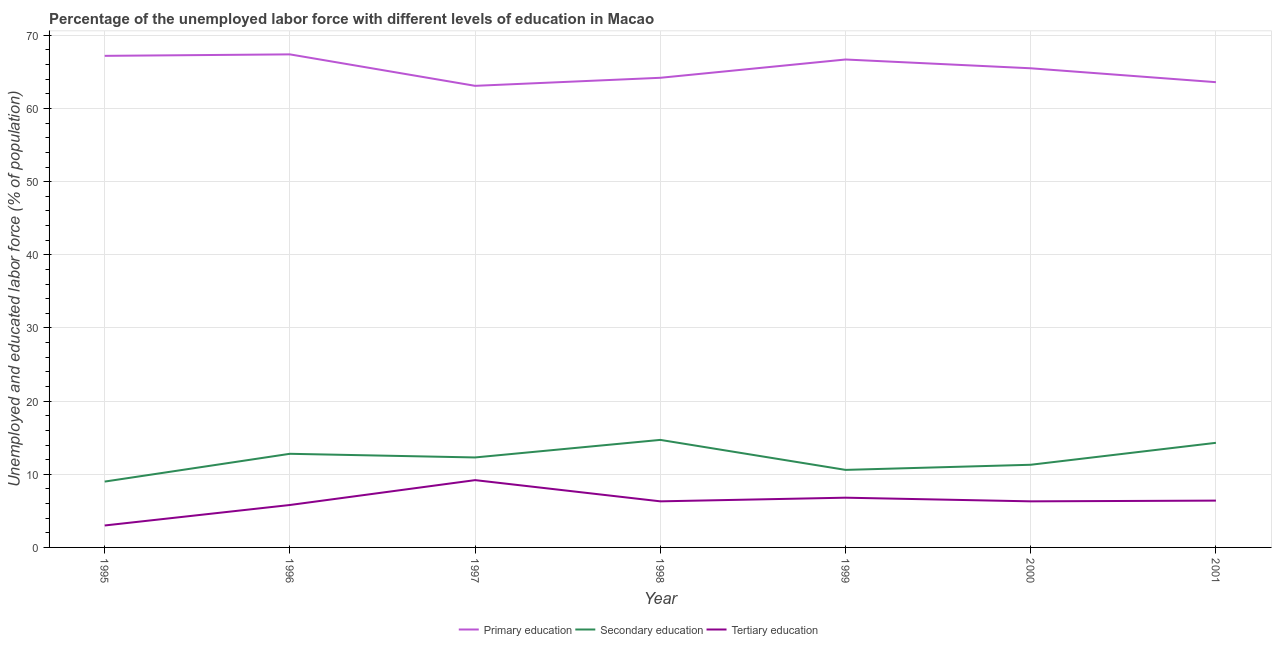Does the line corresponding to percentage of labor force who received secondary education intersect with the line corresponding to percentage of labor force who received tertiary education?
Keep it short and to the point. No. What is the percentage of labor force who received tertiary education in 2000?
Offer a very short reply. 6.3. Across all years, what is the maximum percentage of labor force who received primary education?
Provide a short and direct response. 67.4. Across all years, what is the minimum percentage of labor force who received tertiary education?
Keep it short and to the point. 3. In which year was the percentage of labor force who received secondary education maximum?
Give a very brief answer. 1998. In which year was the percentage of labor force who received primary education minimum?
Offer a terse response. 1997. What is the total percentage of labor force who received secondary education in the graph?
Your answer should be compact. 85. What is the difference between the percentage of labor force who received primary education in 1997 and that in 1998?
Offer a very short reply. -1.1. What is the difference between the percentage of labor force who received primary education in 1997 and the percentage of labor force who received secondary education in 1995?
Ensure brevity in your answer.  54.1. What is the average percentage of labor force who received secondary education per year?
Offer a very short reply. 12.14. In the year 2000, what is the difference between the percentage of labor force who received secondary education and percentage of labor force who received primary education?
Provide a succinct answer. -54.2. What is the ratio of the percentage of labor force who received secondary education in 1995 to that in 1997?
Provide a succinct answer. 0.73. Is the difference between the percentage of labor force who received primary education in 1996 and 2001 greater than the difference between the percentage of labor force who received secondary education in 1996 and 2001?
Make the answer very short. Yes. What is the difference between the highest and the second highest percentage of labor force who received primary education?
Your answer should be compact. 0.2. What is the difference between the highest and the lowest percentage of labor force who received tertiary education?
Keep it short and to the point. 6.2. In how many years, is the percentage of labor force who received secondary education greater than the average percentage of labor force who received secondary education taken over all years?
Keep it short and to the point. 4. Is the sum of the percentage of labor force who received tertiary education in 1997 and 2001 greater than the maximum percentage of labor force who received primary education across all years?
Provide a succinct answer. No. Is it the case that in every year, the sum of the percentage of labor force who received primary education and percentage of labor force who received secondary education is greater than the percentage of labor force who received tertiary education?
Ensure brevity in your answer.  Yes. What is the difference between two consecutive major ticks on the Y-axis?
Your answer should be very brief. 10. Does the graph contain any zero values?
Offer a terse response. No. Where does the legend appear in the graph?
Offer a terse response. Bottom center. How many legend labels are there?
Your response must be concise. 3. How are the legend labels stacked?
Offer a very short reply. Horizontal. What is the title of the graph?
Provide a succinct answer. Percentage of the unemployed labor force with different levels of education in Macao. What is the label or title of the X-axis?
Make the answer very short. Year. What is the label or title of the Y-axis?
Offer a terse response. Unemployed and educated labor force (% of population). What is the Unemployed and educated labor force (% of population) in Primary education in 1995?
Ensure brevity in your answer.  67.2. What is the Unemployed and educated labor force (% of population) in Secondary education in 1995?
Your answer should be very brief. 9. What is the Unemployed and educated labor force (% of population) of Tertiary education in 1995?
Offer a terse response. 3. What is the Unemployed and educated labor force (% of population) in Primary education in 1996?
Your answer should be very brief. 67.4. What is the Unemployed and educated labor force (% of population) of Secondary education in 1996?
Ensure brevity in your answer.  12.8. What is the Unemployed and educated labor force (% of population) in Tertiary education in 1996?
Provide a succinct answer. 5.8. What is the Unemployed and educated labor force (% of population) of Primary education in 1997?
Give a very brief answer. 63.1. What is the Unemployed and educated labor force (% of population) of Secondary education in 1997?
Keep it short and to the point. 12.3. What is the Unemployed and educated labor force (% of population) in Tertiary education in 1997?
Offer a terse response. 9.2. What is the Unemployed and educated labor force (% of population) of Primary education in 1998?
Offer a terse response. 64.2. What is the Unemployed and educated labor force (% of population) in Secondary education in 1998?
Ensure brevity in your answer.  14.7. What is the Unemployed and educated labor force (% of population) of Tertiary education in 1998?
Offer a terse response. 6.3. What is the Unemployed and educated labor force (% of population) in Primary education in 1999?
Provide a short and direct response. 66.7. What is the Unemployed and educated labor force (% of population) of Secondary education in 1999?
Keep it short and to the point. 10.6. What is the Unemployed and educated labor force (% of population) of Tertiary education in 1999?
Your answer should be compact. 6.8. What is the Unemployed and educated labor force (% of population) in Primary education in 2000?
Offer a terse response. 65.5. What is the Unemployed and educated labor force (% of population) in Secondary education in 2000?
Your answer should be very brief. 11.3. What is the Unemployed and educated labor force (% of population) in Tertiary education in 2000?
Offer a very short reply. 6.3. What is the Unemployed and educated labor force (% of population) of Primary education in 2001?
Your answer should be very brief. 63.6. What is the Unemployed and educated labor force (% of population) of Secondary education in 2001?
Make the answer very short. 14.3. What is the Unemployed and educated labor force (% of population) in Tertiary education in 2001?
Offer a terse response. 6.4. Across all years, what is the maximum Unemployed and educated labor force (% of population) in Primary education?
Ensure brevity in your answer.  67.4. Across all years, what is the maximum Unemployed and educated labor force (% of population) in Secondary education?
Provide a short and direct response. 14.7. Across all years, what is the maximum Unemployed and educated labor force (% of population) in Tertiary education?
Ensure brevity in your answer.  9.2. Across all years, what is the minimum Unemployed and educated labor force (% of population) of Primary education?
Your answer should be very brief. 63.1. Across all years, what is the minimum Unemployed and educated labor force (% of population) in Tertiary education?
Keep it short and to the point. 3. What is the total Unemployed and educated labor force (% of population) in Primary education in the graph?
Provide a succinct answer. 457.7. What is the total Unemployed and educated labor force (% of population) of Secondary education in the graph?
Give a very brief answer. 85. What is the total Unemployed and educated labor force (% of population) in Tertiary education in the graph?
Make the answer very short. 43.8. What is the difference between the Unemployed and educated labor force (% of population) in Secondary education in 1995 and that in 1997?
Make the answer very short. -3.3. What is the difference between the Unemployed and educated labor force (% of population) of Tertiary education in 1995 and that in 1997?
Keep it short and to the point. -6.2. What is the difference between the Unemployed and educated labor force (% of population) of Tertiary education in 1995 and that in 1998?
Your response must be concise. -3.3. What is the difference between the Unemployed and educated labor force (% of population) in Secondary education in 1995 and that in 1999?
Provide a succinct answer. -1.6. What is the difference between the Unemployed and educated labor force (% of population) of Tertiary education in 1995 and that in 1999?
Your response must be concise. -3.8. What is the difference between the Unemployed and educated labor force (% of population) of Primary education in 1995 and that in 2000?
Make the answer very short. 1.7. What is the difference between the Unemployed and educated labor force (% of population) in Secondary education in 1995 and that in 2000?
Offer a very short reply. -2.3. What is the difference between the Unemployed and educated labor force (% of population) of Primary education in 1995 and that in 2001?
Provide a short and direct response. 3.6. What is the difference between the Unemployed and educated labor force (% of population) of Secondary education in 1996 and that in 1997?
Offer a very short reply. 0.5. What is the difference between the Unemployed and educated labor force (% of population) of Primary education in 1996 and that in 1998?
Provide a short and direct response. 3.2. What is the difference between the Unemployed and educated labor force (% of population) of Secondary education in 1996 and that in 1999?
Your response must be concise. 2.2. What is the difference between the Unemployed and educated labor force (% of population) in Tertiary education in 1996 and that in 2000?
Give a very brief answer. -0.5. What is the difference between the Unemployed and educated labor force (% of population) in Tertiary education in 1996 and that in 2001?
Your answer should be very brief. -0.6. What is the difference between the Unemployed and educated labor force (% of population) in Primary education in 1997 and that in 1998?
Keep it short and to the point. -1.1. What is the difference between the Unemployed and educated labor force (% of population) of Secondary education in 1997 and that in 1998?
Give a very brief answer. -2.4. What is the difference between the Unemployed and educated labor force (% of population) of Tertiary education in 1997 and that in 1998?
Ensure brevity in your answer.  2.9. What is the difference between the Unemployed and educated labor force (% of population) in Primary education in 1997 and that in 1999?
Offer a very short reply. -3.6. What is the difference between the Unemployed and educated labor force (% of population) of Tertiary education in 1997 and that in 1999?
Keep it short and to the point. 2.4. What is the difference between the Unemployed and educated labor force (% of population) of Primary education in 1997 and that in 2000?
Give a very brief answer. -2.4. What is the difference between the Unemployed and educated labor force (% of population) of Tertiary education in 1997 and that in 2000?
Keep it short and to the point. 2.9. What is the difference between the Unemployed and educated labor force (% of population) of Tertiary education in 1997 and that in 2001?
Offer a very short reply. 2.8. What is the difference between the Unemployed and educated labor force (% of population) of Secondary education in 1998 and that in 1999?
Ensure brevity in your answer.  4.1. What is the difference between the Unemployed and educated labor force (% of population) of Primary education in 1998 and that in 2000?
Provide a succinct answer. -1.3. What is the difference between the Unemployed and educated labor force (% of population) of Primary education in 1998 and that in 2001?
Ensure brevity in your answer.  0.6. What is the difference between the Unemployed and educated labor force (% of population) of Secondary education in 1998 and that in 2001?
Your answer should be very brief. 0.4. What is the difference between the Unemployed and educated labor force (% of population) in Primary education in 1999 and that in 2000?
Your answer should be compact. 1.2. What is the difference between the Unemployed and educated labor force (% of population) of Secondary education in 1999 and that in 2001?
Your answer should be compact. -3.7. What is the difference between the Unemployed and educated labor force (% of population) in Tertiary education in 1999 and that in 2001?
Provide a succinct answer. 0.4. What is the difference between the Unemployed and educated labor force (% of population) in Secondary education in 2000 and that in 2001?
Provide a succinct answer. -3. What is the difference between the Unemployed and educated labor force (% of population) of Tertiary education in 2000 and that in 2001?
Make the answer very short. -0.1. What is the difference between the Unemployed and educated labor force (% of population) in Primary education in 1995 and the Unemployed and educated labor force (% of population) in Secondary education in 1996?
Keep it short and to the point. 54.4. What is the difference between the Unemployed and educated labor force (% of population) in Primary education in 1995 and the Unemployed and educated labor force (% of population) in Tertiary education in 1996?
Your answer should be compact. 61.4. What is the difference between the Unemployed and educated labor force (% of population) in Primary education in 1995 and the Unemployed and educated labor force (% of population) in Secondary education in 1997?
Provide a succinct answer. 54.9. What is the difference between the Unemployed and educated labor force (% of population) of Secondary education in 1995 and the Unemployed and educated labor force (% of population) of Tertiary education in 1997?
Provide a succinct answer. -0.2. What is the difference between the Unemployed and educated labor force (% of population) in Primary education in 1995 and the Unemployed and educated labor force (% of population) in Secondary education in 1998?
Provide a succinct answer. 52.5. What is the difference between the Unemployed and educated labor force (% of population) of Primary education in 1995 and the Unemployed and educated labor force (% of population) of Tertiary education in 1998?
Make the answer very short. 60.9. What is the difference between the Unemployed and educated labor force (% of population) in Secondary education in 1995 and the Unemployed and educated labor force (% of population) in Tertiary education in 1998?
Offer a very short reply. 2.7. What is the difference between the Unemployed and educated labor force (% of population) of Primary education in 1995 and the Unemployed and educated labor force (% of population) of Secondary education in 1999?
Your response must be concise. 56.6. What is the difference between the Unemployed and educated labor force (% of population) of Primary education in 1995 and the Unemployed and educated labor force (% of population) of Tertiary education in 1999?
Keep it short and to the point. 60.4. What is the difference between the Unemployed and educated labor force (% of population) of Secondary education in 1995 and the Unemployed and educated labor force (% of population) of Tertiary education in 1999?
Your response must be concise. 2.2. What is the difference between the Unemployed and educated labor force (% of population) of Primary education in 1995 and the Unemployed and educated labor force (% of population) of Secondary education in 2000?
Make the answer very short. 55.9. What is the difference between the Unemployed and educated labor force (% of population) in Primary education in 1995 and the Unemployed and educated labor force (% of population) in Tertiary education in 2000?
Your answer should be very brief. 60.9. What is the difference between the Unemployed and educated labor force (% of population) in Primary education in 1995 and the Unemployed and educated labor force (% of population) in Secondary education in 2001?
Your response must be concise. 52.9. What is the difference between the Unemployed and educated labor force (% of population) in Primary education in 1995 and the Unemployed and educated labor force (% of population) in Tertiary education in 2001?
Your response must be concise. 60.8. What is the difference between the Unemployed and educated labor force (% of population) of Primary education in 1996 and the Unemployed and educated labor force (% of population) of Secondary education in 1997?
Make the answer very short. 55.1. What is the difference between the Unemployed and educated labor force (% of population) in Primary education in 1996 and the Unemployed and educated labor force (% of population) in Tertiary education in 1997?
Offer a very short reply. 58.2. What is the difference between the Unemployed and educated labor force (% of population) of Primary education in 1996 and the Unemployed and educated labor force (% of population) of Secondary education in 1998?
Provide a short and direct response. 52.7. What is the difference between the Unemployed and educated labor force (% of population) in Primary education in 1996 and the Unemployed and educated labor force (% of population) in Tertiary education in 1998?
Offer a very short reply. 61.1. What is the difference between the Unemployed and educated labor force (% of population) in Primary education in 1996 and the Unemployed and educated labor force (% of population) in Secondary education in 1999?
Give a very brief answer. 56.8. What is the difference between the Unemployed and educated labor force (% of population) of Primary education in 1996 and the Unemployed and educated labor force (% of population) of Tertiary education in 1999?
Offer a very short reply. 60.6. What is the difference between the Unemployed and educated labor force (% of population) of Primary education in 1996 and the Unemployed and educated labor force (% of population) of Secondary education in 2000?
Keep it short and to the point. 56.1. What is the difference between the Unemployed and educated labor force (% of population) in Primary education in 1996 and the Unemployed and educated labor force (% of population) in Tertiary education in 2000?
Your answer should be compact. 61.1. What is the difference between the Unemployed and educated labor force (% of population) in Secondary education in 1996 and the Unemployed and educated labor force (% of population) in Tertiary education in 2000?
Your answer should be compact. 6.5. What is the difference between the Unemployed and educated labor force (% of population) of Primary education in 1996 and the Unemployed and educated labor force (% of population) of Secondary education in 2001?
Your response must be concise. 53.1. What is the difference between the Unemployed and educated labor force (% of population) in Secondary education in 1996 and the Unemployed and educated labor force (% of population) in Tertiary education in 2001?
Your answer should be very brief. 6.4. What is the difference between the Unemployed and educated labor force (% of population) in Primary education in 1997 and the Unemployed and educated labor force (% of population) in Secondary education in 1998?
Provide a succinct answer. 48.4. What is the difference between the Unemployed and educated labor force (% of population) of Primary education in 1997 and the Unemployed and educated labor force (% of population) of Tertiary education in 1998?
Ensure brevity in your answer.  56.8. What is the difference between the Unemployed and educated labor force (% of population) of Primary education in 1997 and the Unemployed and educated labor force (% of population) of Secondary education in 1999?
Ensure brevity in your answer.  52.5. What is the difference between the Unemployed and educated labor force (% of population) of Primary education in 1997 and the Unemployed and educated labor force (% of population) of Tertiary education in 1999?
Your answer should be compact. 56.3. What is the difference between the Unemployed and educated labor force (% of population) of Secondary education in 1997 and the Unemployed and educated labor force (% of population) of Tertiary education in 1999?
Provide a succinct answer. 5.5. What is the difference between the Unemployed and educated labor force (% of population) of Primary education in 1997 and the Unemployed and educated labor force (% of population) of Secondary education in 2000?
Give a very brief answer. 51.8. What is the difference between the Unemployed and educated labor force (% of population) of Primary education in 1997 and the Unemployed and educated labor force (% of population) of Tertiary education in 2000?
Give a very brief answer. 56.8. What is the difference between the Unemployed and educated labor force (% of population) in Primary education in 1997 and the Unemployed and educated labor force (% of population) in Secondary education in 2001?
Offer a terse response. 48.8. What is the difference between the Unemployed and educated labor force (% of population) of Primary education in 1997 and the Unemployed and educated labor force (% of population) of Tertiary education in 2001?
Offer a very short reply. 56.7. What is the difference between the Unemployed and educated labor force (% of population) in Primary education in 1998 and the Unemployed and educated labor force (% of population) in Secondary education in 1999?
Give a very brief answer. 53.6. What is the difference between the Unemployed and educated labor force (% of population) in Primary education in 1998 and the Unemployed and educated labor force (% of population) in Tertiary education in 1999?
Make the answer very short. 57.4. What is the difference between the Unemployed and educated labor force (% of population) in Secondary education in 1998 and the Unemployed and educated labor force (% of population) in Tertiary education in 1999?
Provide a short and direct response. 7.9. What is the difference between the Unemployed and educated labor force (% of population) of Primary education in 1998 and the Unemployed and educated labor force (% of population) of Secondary education in 2000?
Make the answer very short. 52.9. What is the difference between the Unemployed and educated labor force (% of population) in Primary education in 1998 and the Unemployed and educated labor force (% of population) in Tertiary education in 2000?
Your answer should be very brief. 57.9. What is the difference between the Unemployed and educated labor force (% of population) in Primary education in 1998 and the Unemployed and educated labor force (% of population) in Secondary education in 2001?
Provide a short and direct response. 49.9. What is the difference between the Unemployed and educated labor force (% of population) in Primary education in 1998 and the Unemployed and educated labor force (% of population) in Tertiary education in 2001?
Provide a succinct answer. 57.8. What is the difference between the Unemployed and educated labor force (% of population) of Secondary education in 1998 and the Unemployed and educated labor force (% of population) of Tertiary education in 2001?
Make the answer very short. 8.3. What is the difference between the Unemployed and educated labor force (% of population) in Primary education in 1999 and the Unemployed and educated labor force (% of population) in Secondary education in 2000?
Provide a short and direct response. 55.4. What is the difference between the Unemployed and educated labor force (% of population) of Primary education in 1999 and the Unemployed and educated labor force (% of population) of Tertiary education in 2000?
Offer a terse response. 60.4. What is the difference between the Unemployed and educated labor force (% of population) in Primary education in 1999 and the Unemployed and educated labor force (% of population) in Secondary education in 2001?
Make the answer very short. 52.4. What is the difference between the Unemployed and educated labor force (% of population) of Primary education in 1999 and the Unemployed and educated labor force (% of population) of Tertiary education in 2001?
Provide a succinct answer. 60.3. What is the difference between the Unemployed and educated labor force (% of population) of Secondary education in 1999 and the Unemployed and educated labor force (% of population) of Tertiary education in 2001?
Provide a succinct answer. 4.2. What is the difference between the Unemployed and educated labor force (% of population) of Primary education in 2000 and the Unemployed and educated labor force (% of population) of Secondary education in 2001?
Offer a terse response. 51.2. What is the difference between the Unemployed and educated labor force (% of population) in Primary education in 2000 and the Unemployed and educated labor force (% of population) in Tertiary education in 2001?
Provide a short and direct response. 59.1. What is the average Unemployed and educated labor force (% of population) in Primary education per year?
Ensure brevity in your answer.  65.39. What is the average Unemployed and educated labor force (% of population) of Secondary education per year?
Offer a terse response. 12.14. What is the average Unemployed and educated labor force (% of population) of Tertiary education per year?
Ensure brevity in your answer.  6.26. In the year 1995, what is the difference between the Unemployed and educated labor force (% of population) of Primary education and Unemployed and educated labor force (% of population) of Secondary education?
Give a very brief answer. 58.2. In the year 1995, what is the difference between the Unemployed and educated labor force (% of population) in Primary education and Unemployed and educated labor force (% of population) in Tertiary education?
Provide a succinct answer. 64.2. In the year 1995, what is the difference between the Unemployed and educated labor force (% of population) in Secondary education and Unemployed and educated labor force (% of population) in Tertiary education?
Offer a very short reply. 6. In the year 1996, what is the difference between the Unemployed and educated labor force (% of population) of Primary education and Unemployed and educated labor force (% of population) of Secondary education?
Keep it short and to the point. 54.6. In the year 1996, what is the difference between the Unemployed and educated labor force (% of population) in Primary education and Unemployed and educated labor force (% of population) in Tertiary education?
Provide a succinct answer. 61.6. In the year 1997, what is the difference between the Unemployed and educated labor force (% of population) in Primary education and Unemployed and educated labor force (% of population) in Secondary education?
Make the answer very short. 50.8. In the year 1997, what is the difference between the Unemployed and educated labor force (% of population) of Primary education and Unemployed and educated labor force (% of population) of Tertiary education?
Your response must be concise. 53.9. In the year 1998, what is the difference between the Unemployed and educated labor force (% of population) in Primary education and Unemployed and educated labor force (% of population) in Secondary education?
Make the answer very short. 49.5. In the year 1998, what is the difference between the Unemployed and educated labor force (% of population) of Primary education and Unemployed and educated labor force (% of population) of Tertiary education?
Offer a terse response. 57.9. In the year 1999, what is the difference between the Unemployed and educated labor force (% of population) of Primary education and Unemployed and educated labor force (% of population) of Secondary education?
Your answer should be very brief. 56.1. In the year 1999, what is the difference between the Unemployed and educated labor force (% of population) of Primary education and Unemployed and educated labor force (% of population) of Tertiary education?
Your answer should be very brief. 59.9. In the year 1999, what is the difference between the Unemployed and educated labor force (% of population) of Secondary education and Unemployed and educated labor force (% of population) of Tertiary education?
Provide a succinct answer. 3.8. In the year 2000, what is the difference between the Unemployed and educated labor force (% of population) of Primary education and Unemployed and educated labor force (% of population) of Secondary education?
Provide a short and direct response. 54.2. In the year 2000, what is the difference between the Unemployed and educated labor force (% of population) in Primary education and Unemployed and educated labor force (% of population) in Tertiary education?
Keep it short and to the point. 59.2. In the year 2001, what is the difference between the Unemployed and educated labor force (% of population) of Primary education and Unemployed and educated labor force (% of population) of Secondary education?
Provide a succinct answer. 49.3. In the year 2001, what is the difference between the Unemployed and educated labor force (% of population) in Primary education and Unemployed and educated labor force (% of population) in Tertiary education?
Offer a very short reply. 57.2. What is the ratio of the Unemployed and educated labor force (% of population) of Secondary education in 1995 to that in 1996?
Keep it short and to the point. 0.7. What is the ratio of the Unemployed and educated labor force (% of population) in Tertiary education in 1995 to that in 1996?
Offer a very short reply. 0.52. What is the ratio of the Unemployed and educated labor force (% of population) of Primary education in 1995 to that in 1997?
Your response must be concise. 1.06. What is the ratio of the Unemployed and educated labor force (% of population) of Secondary education in 1995 to that in 1997?
Offer a very short reply. 0.73. What is the ratio of the Unemployed and educated labor force (% of population) of Tertiary education in 1995 to that in 1997?
Your response must be concise. 0.33. What is the ratio of the Unemployed and educated labor force (% of population) of Primary education in 1995 to that in 1998?
Offer a very short reply. 1.05. What is the ratio of the Unemployed and educated labor force (% of population) in Secondary education in 1995 to that in 1998?
Give a very brief answer. 0.61. What is the ratio of the Unemployed and educated labor force (% of population) in Tertiary education in 1995 to that in 1998?
Provide a short and direct response. 0.48. What is the ratio of the Unemployed and educated labor force (% of population) of Primary education in 1995 to that in 1999?
Offer a very short reply. 1.01. What is the ratio of the Unemployed and educated labor force (% of population) of Secondary education in 1995 to that in 1999?
Your answer should be compact. 0.85. What is the ratio of the Unemployed and educated labor force (% of population) of Tertiary education in 1995 to that in 1999?
Provide a succinct answer. 0.44. What is the ratio of the Unemployed and educated labor force (% of population) of Primary education in 1995 to that in 2000?
Ensure brevity in your answer.  1.03. What is the ratio of the Unemployed and educated labor force (% of population) of Secondary education in 1995 to that in 2000?
Offer a terse response. 0.8. What is the ratio of the Unemployed and educated labor force (% of population) in Tertiary education in 1995 to that in 2000?
Your answer should be very brief. 0.48. What is the ratio of the Unemployed and educated labor force (% of population) of Primary education in 1995 to that in 2001?
Offer a terse response. 1.06. What is the ratio of the Unemployed and educated labor force (% of population) in Secondary education in 1995 to that in 2001?
Offer a terse response. 0.63. What is the ratio of the Unemployed and educated labor force (% of population) of Tertiary education in 1995 to that in 2001?
Your answer should be compact. 0.47. What is the ratio of the Unemployed and educated labor force (% of population) in Primary education in 1996 to that in 1997?
Make the answer very short. 1.07. What is the ratio of the Unemployed and educated labor force (% of population) in Secondary education in 1996 to that in 1997?
Your answer should be compact. 1.04. What is the ratio of the Unemployed and educated labor force (% of population) in Tertiary education in 1996 to that in 1997?
Offer a terse response. 0.63. What is the ratio of the Unemployed and educated labor force (% of population) in Primary education in 1996 to that in 1998?
Give a very brief answer. 1.05. What is the ratio of the Unemployed and educated labor force (% of population) of Secondary education in 1996 to that in 1998?
Your answer should be very brief. 0.87. What is the ratio of the Unemployed and educated labor force (% of population) in Tertiary education in 1996 to that in 1998?
Provide a short and direct response. 0.92. What is the ratio of the Unemployed and educated labor force (% of population) in Primary education in 1996 to that in 1999?
Your answer should be compact. 1.01. What is the ratio of the Unemployed and educated labor force (% of population) of Secondary education in 1996 to that in 1999?
Give a very brief answer. 1.21. What is the ratio of the Unemployed and educated labor force (% of population) in Tertiary education in 1996 to that in 1999?
Your answer should be very brief. 0.85. What is the ratio of the Unemployed and educated labor force (% of population) in Secondary education in 1996 to that in 2000?
Ensure brevity in your answer.  1.13. What is the ratio of the Unemployed and educated labor force (% of population) in Tertiary education in 1996 to that in 2000?
Your response must be concise. 0.92. What is the ratio of the Unemployed and educated labor force (% of population) of Primary education in 1996 to that in 2001?
Your answer should be compact. 1.06. What is the ratio of the Unemployed and educated labor force (% of population) in Secondary education in 1996 to that in 2001?
Give a very brief answer. 0.9. What is the ratio of the Unemployed and educated labor force (% of population) of Tertiary education in 1996 to that in 2001?
Your answer should be very brief. 0.91. What is the ratio of the Unemployed and educated labor force (% of population) in Primary education in 1997 to that in 1998?
Keep it short and to the point. 0.98. What is the ratio of the Unemployed and educated labor force (% of population) of Secondary education in 1997 to that in 1998?
Keep it short and to the point. 0.84. What is the ratio of the Unemployed and educated labor force (% of population) of Tertiary education in 1997 to that in 1998?
Your answer should be very brief. 1.46. What is the ratio of the Unemployed and educated labor force (% of population) in Primary education in 1997 to that in 1999?
Offer a terse response. 0.95. What is the ratio of the Unemployed and educated labor force (% of population) in Secondary education in 1997 to that in 1999?
Offer a terse response. 1.16. What is the ratio of the Unemployed and educated labor force (% of population) of Tertiary education in 1997 to that in 1999?
Make the answer very short. 1.35. What is the ratio of the Unemployed and educated labor force (% of population) in Primary education in 1997 to that in 2000?
Ensure brevity in your answer.  0.96. What is the ratio of the Unemployed and educated labor force (% of population) in Secondary education in 1997 to that in 2000?
Your response must be concise. 1.09. What is the ratio of the Unemployed and educated labor force (% of population) in Tertiary education in 1997 to that in 2000?
Provide a succinct answer. 1.46. What is the ratio of the Unemployed and educated labor force (% of population) in Secondary education in 1997 to that in 2001?
Ensure brevity in your answer.  0.86. What is the ratio of the Unemployed and educated labor force (% of population) of Tertiary education in 1997 to that in 2001?
Provide a short and direct response. 1.44. What is the ratio of the Unemployed and educated labor force (% of population) in Primary education in 1998 to that in 1999?
Your answer should be compact. 0.96. What is the ratio of the Unemployed and educated labor force (% of population) in Secondary education in 1998 to that in 1999?
Offer a terse response. 1.39. What is the ratio of the Unemployed and educated labor force (% of population) of Tertiary education in 1998 to that in 1999?
Offer a very short reply. 0.93. What is the ratio of the Unemployed and educated labor force (% of population) in Primary education in 1998 to that in 2000?
Make the answer very short. 0.98. What is the ratio of the Unemployed and educated labor force (% of population) in Secondary education in 1998 to that in 2000?
Keep it short and to the point. 1.3. What is the ratio of the Unemployed and educated labor force (% of population) of Primary education in 1998 to that in 2001?
Keep it short and to the point. 1.01. What is the ratio of the Unemployed and educated labor force (% of population) of Secondary education in 1998 to that in 2001?
Offer a terse response. 1.03. What is the ratio of the Unemployed and educated labor force (% of population) of Tertiary education in 1998 to that in 2001?
Offer a terse response. 0.98. What is the ratio of the Unemployed and educated labor force (% of population) of Primary education in 1999 to that in 2000?
Make the answer very short. 1.02. What is the ratio of the Unemployed and educated labor force (% of population) of Secondary education in 1999 to that in 2000?
Offer a terse response. 0.94. What is the ratio of the Unemployed and educated labor force (% of population) in Tertiary education in 1999 to that in 2000?
Your response must be concise. 1.08. What is the ratio of the Unemployed and educated labor force (% of population) in Primary education in 1999 to that in 2001?
Offer a very short reply. 1.05. What is the ratio of the Unemployed and educated labor force (% of population) in Secondary education in 1999 to that in 2001?
Give a very brief answer. 0.74. What is the ratio of the Unemployed and educated labor force (% of population) in Tertiary education in 1999 to that in 2001?
Offer a very short reply. 1.06. What is the ratio of the Unemployed and educated labor force (% of population) in Primary education in 2000 to that in 2001?
Offer a very short reply. 1.03. What is the ratio of the Unemployed and educated labor force (% of population) of Secondary education in 2000 to that in 2001?
Provide a short and direct response. 0.79. What is the ratio of the Unemployed and educated labor force (% of population) of Tertiary education in 2000 to that in 2001?
Offer a terse response. 0.98. What is the difference between the highest and the second highest Unemployed and educated labor force (% of population) of Secondary education?
Offer a terse response. 0.4. What is the difference between the highest and the lowest Unemployed and educated labor force (% of population) of Primary education?
Your answer should be compact. 4.3. 